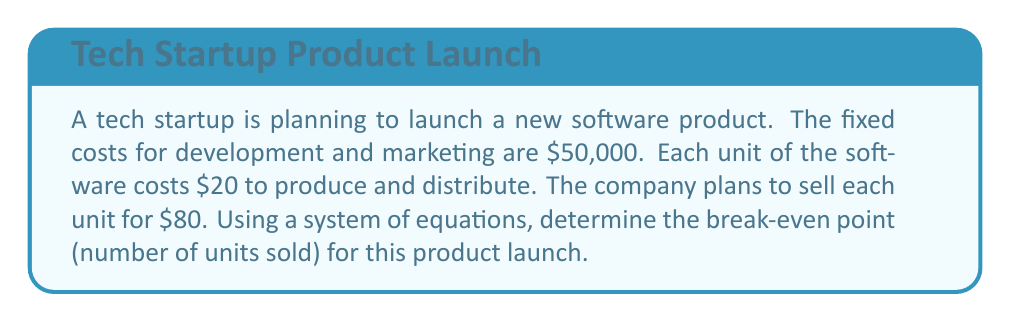Give your solution to this math problem. To solve this problem, we need to set up a system of equations using the given information. Let's define our variables:

$x$ = number of units sold
$y$ = total revenue
$z$ = total costs

1. Set up the equations:

   Revenue equation: $y = 80x$ (price per unit × number of units)
   Cost equation: $z = 50000 + 20x$ (fixed costs + variable costs per unit × number of units)

2. At the break-even point, revenue equals costs, so:

   $y = z$
   $80x = 50000 + 20x$

3. Solve the equation:

   $80x - 20x = 50000$
   $60x = 50000$

4. Divide both sides by 60:

   $x = \frac{50000}{60} = 833.33$

5. Since we can't sell a fraction of a unit, we round up to the nearest whole number:

   $x = 834$ units

To verify:
Revenue at 834 units: $80 \times 834 = 66720$
Costs at 834 units: $50000 + (20 \times 834) = 66680$

The difference of $40 confirms that 834 is the first point where revenue exceeds costs.
Answer: The break-even point for the product launch is 834 units. 